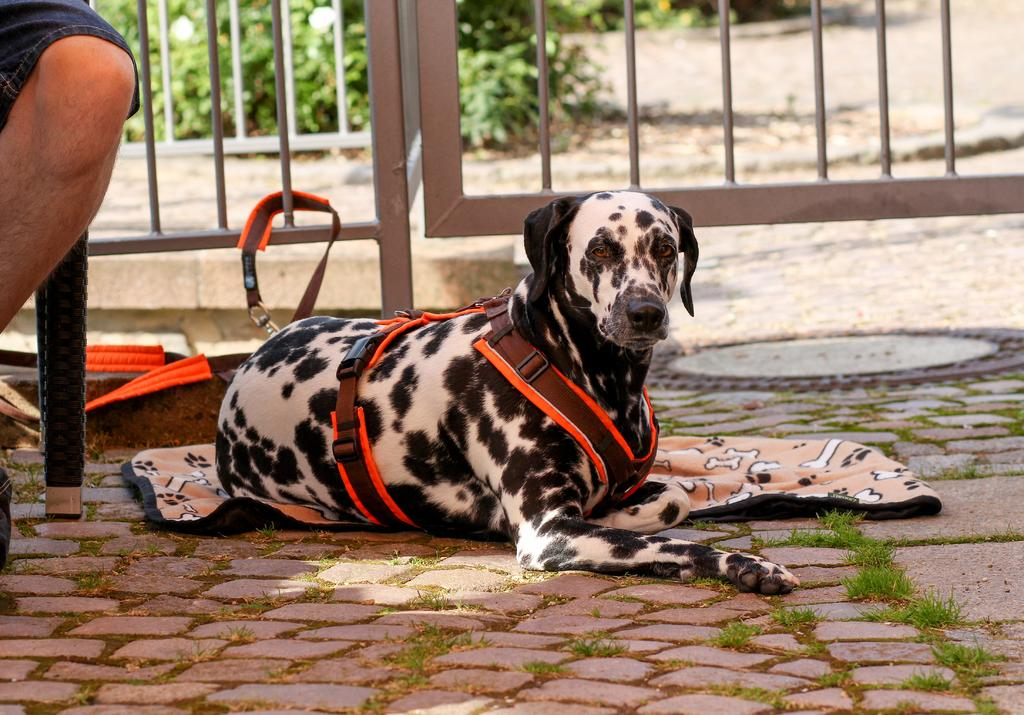What type of animal can be seen in the image? There is a dog in the image. What other living organisms are present in the image? There are plants in the image. What type of ground surface is visible in the image? There is grass in the image. What type of barrier is present in the image? There is a fence in the image. What inanimate object is present in the image? There is a cloth in the image. Can you describe the presence of a person in the image? A person is present in the image, although truncated. What type of sack is being used to draw the attention of the dog in the image? There is no sack present in the image, nor is there any indication of the dog's attention being drawn to anything specific. What is the condition of the person in the image? The person in the image is truncated, so it is impossible to determine their condition. 